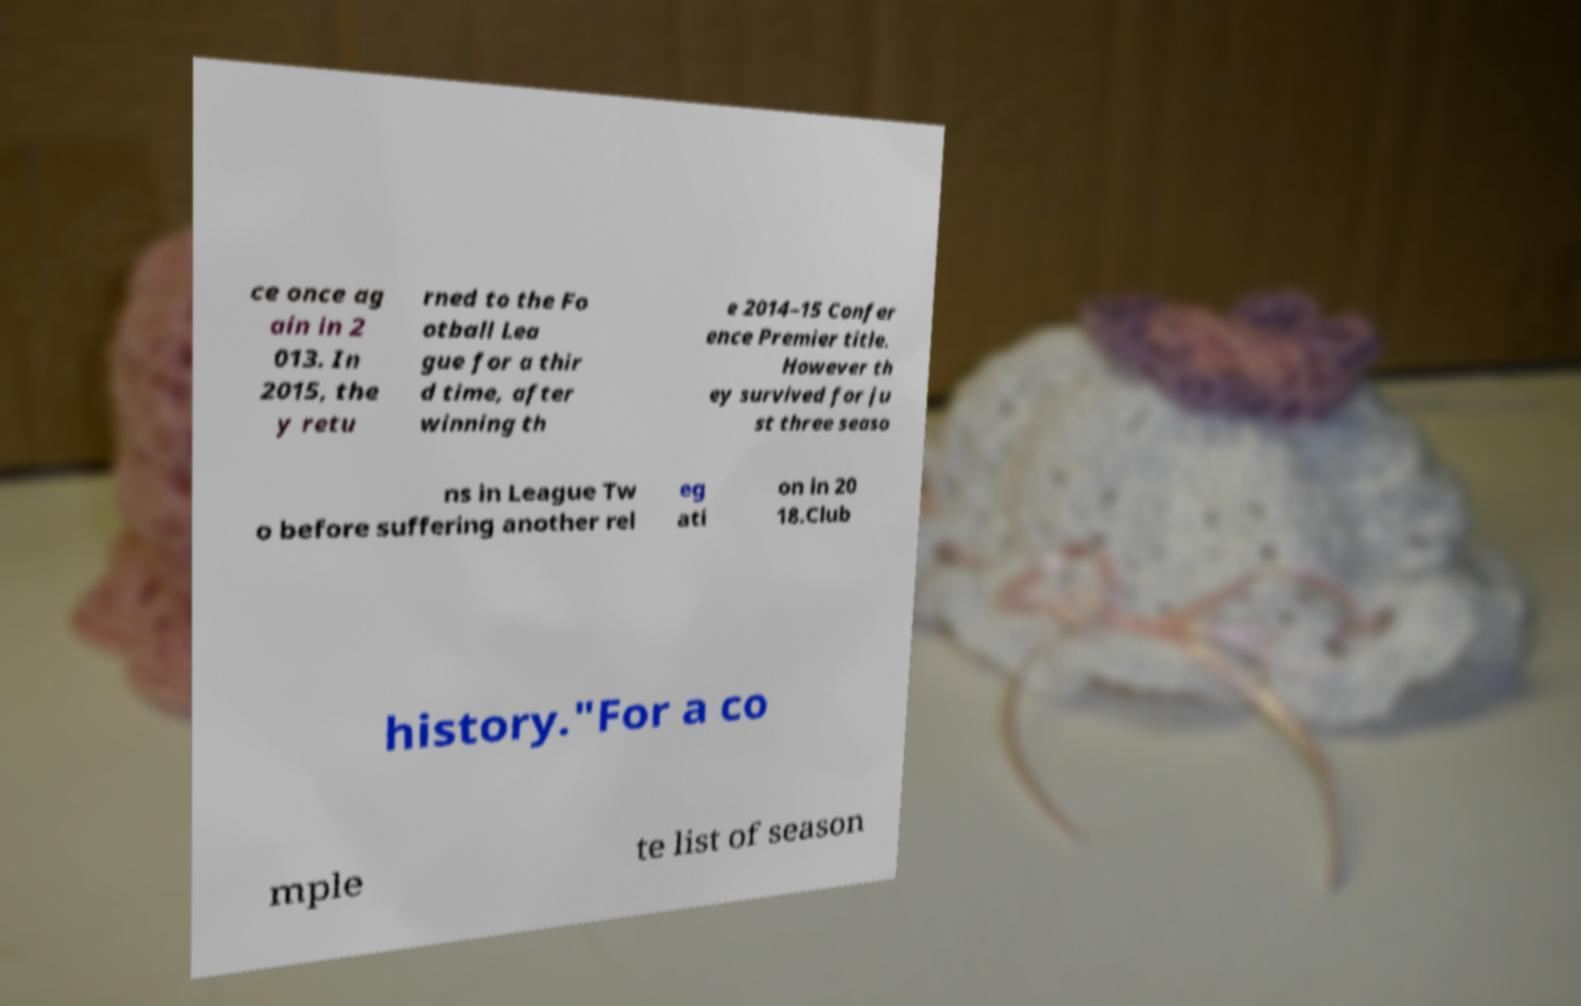Can you accurately transcribe the text from the provided image for me? ce once ag ain in 2 013. In 2015, the y retu rned to the Fo otball Lea gue for a thir d time, after winning th e 2014–15 Confer ence Premier title. However th ey survived for ju st three seaso ns in League Tw o before suffering another rel eg ati on in 20 18.Club history."For a co mple te list of season 